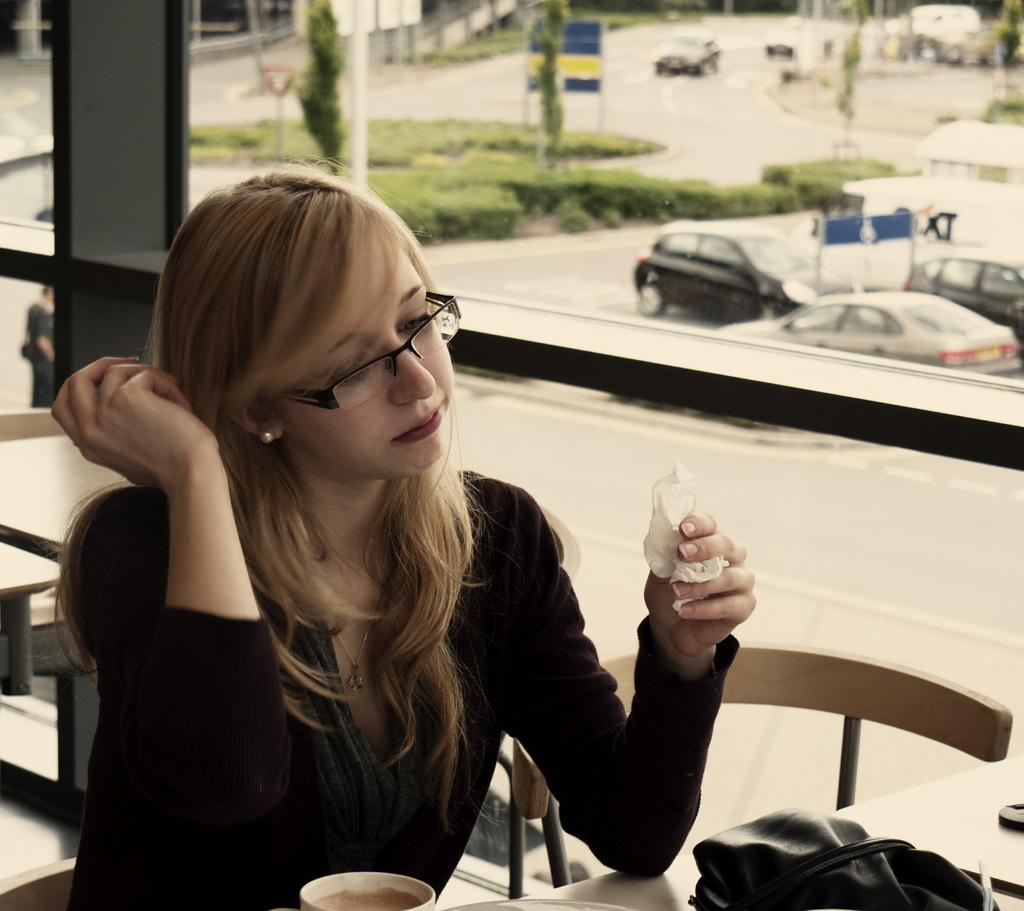Who is present in the image? There is a woman in the image. What is the woman doing in the image? The woman is sitting on a chair. What type of car is the woman using to stick the glue on the account in the image? There is no car, glue, or account present in the image. 